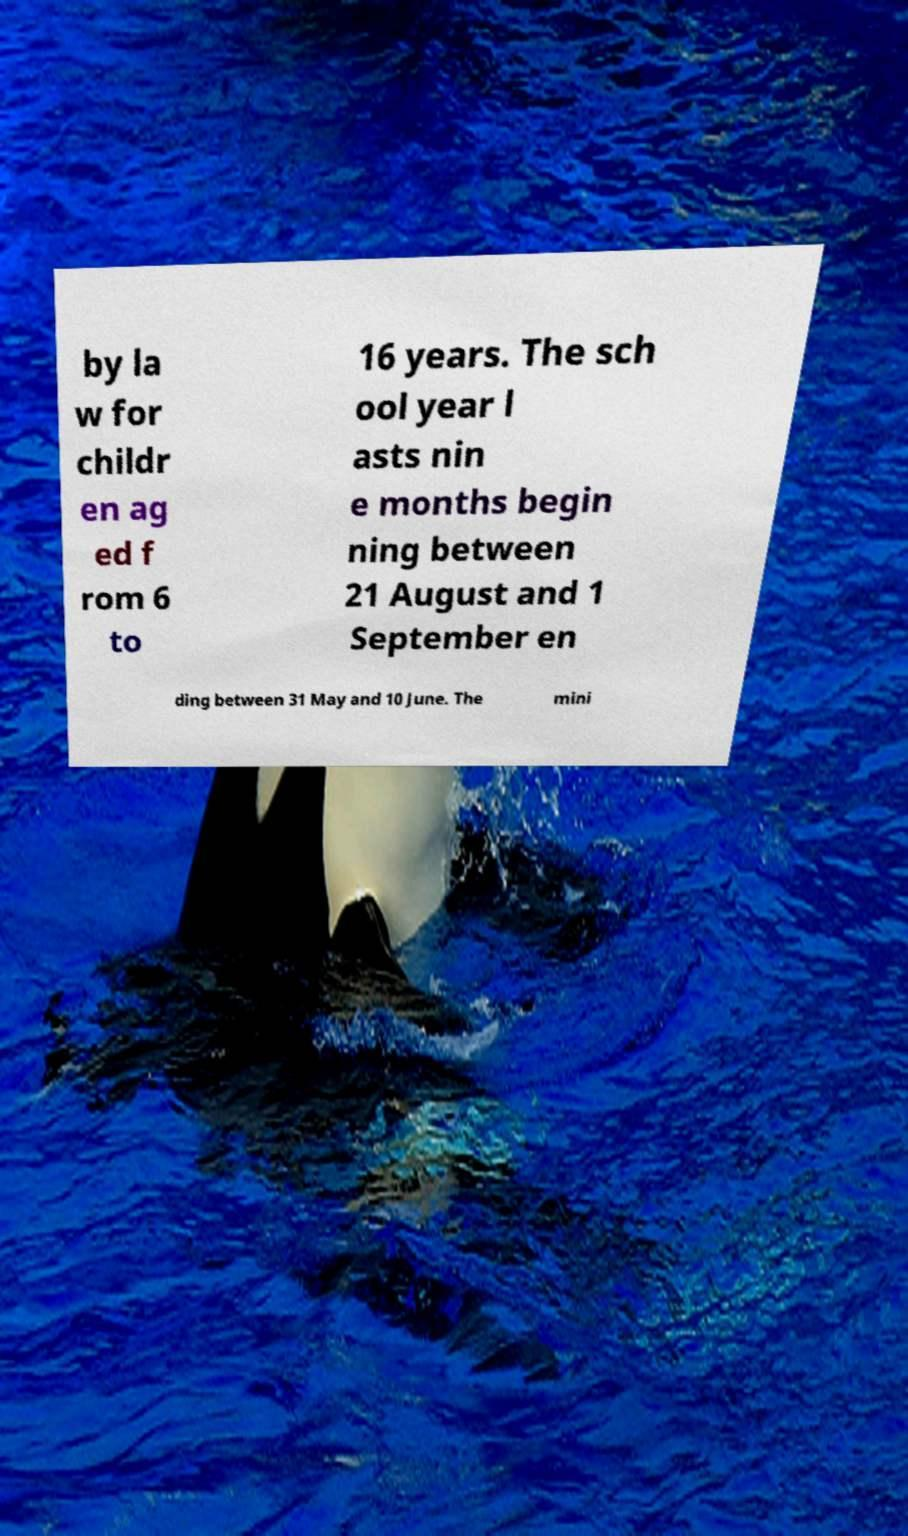I need the written content from this picture converted into text. Can you do that? by la w for childr en ag ed f rom 6 to 16 years. The sch ool year l asts nin e months begin ning between 21 August and 1 September en ding between 31 May and 10 June. The mini 